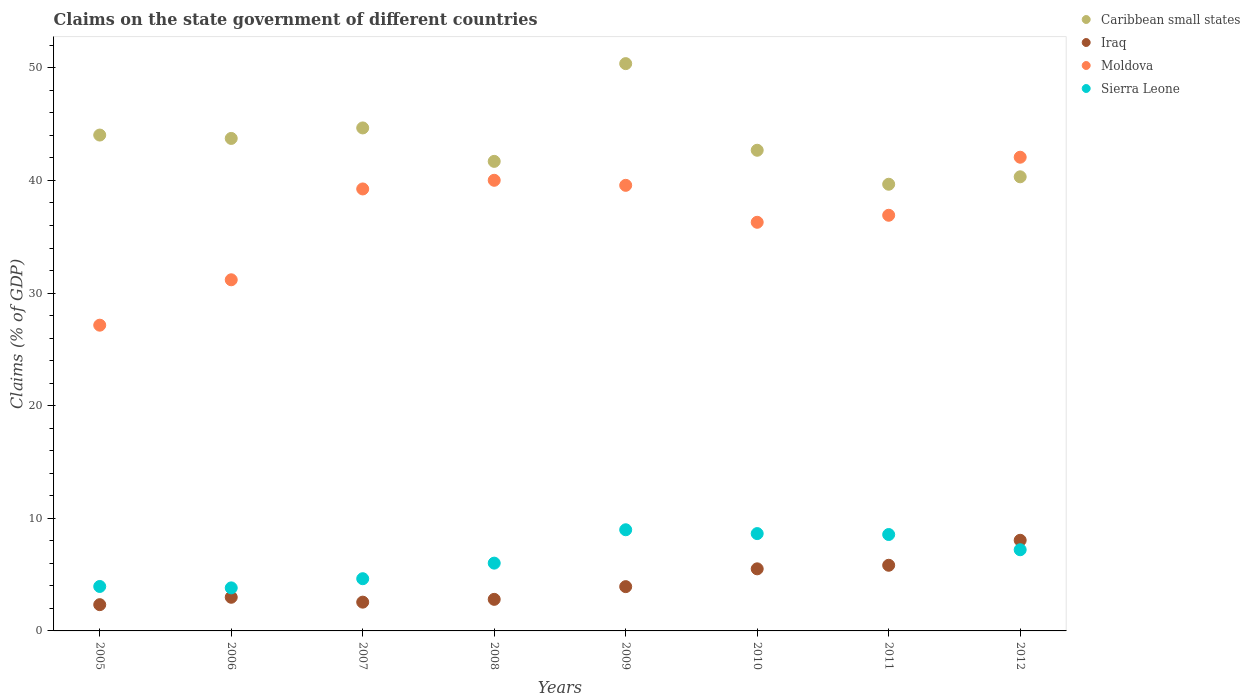Is the number of dotlines equal to the number of legend labels?
Offer a terse response. Yes. What is the percentage of GDP claimed on the state government in Caribbean small states in 2008?
Provide a short and direct response. 41.7. Across all years, what is the maximum percentage of GDP claimed on the state government in Moldova?
Make the answer very short. 42.06. Across all years, what is the minimum percentage of GDP claimed on the state government in Sierra Leone?
Your answer should be compact. 3.82. In which year was the percentage of GDP claimed on the state government in Sierra Leone minimum?
Provide a succinct answer. 2006. What is the total percentage of GDP claimed on the state government in Sierra Leone in the graph?
Ensure brevity in your answer.  51.82. What is the difference between the percentage of GDP claimed on the state government in Iraq in 2005 and that in 2009?
Give a very brief answer. -1.6. What is the difference between the percentage of GDP claimed on the state government in Caribbean small states in 2011 and the percentage of GDP claimed on the state government in Iraq in 2007?
Give a very brief answer. 37.11. What is the average percentage of GDP claimed on the state government in Moldova per year?
Your response must be concise. 36.55. In the year 2009, what is the difference between the percentage of GDP claimed on the state government in Caribbean small states and percentage of GDP claimed on the state government in Moldova?
Keep it short and to the point. 10.81. What is the ratio of the percentage of GDP claimed on the state government in Caribbean small states in 2011 to that in 2012?
Give a very brief answer. 0.98. Is the difference between the percentage of GDP claimed on the state government in Caribbean small states in 2006 and 2009 greater than the difference between the percentage of GDP claimed on the state government in Moldova in 2006 and 2009?
Provide a short and direct response. Yes. What is the difference between the highest and the second highest percentage of GDP claimed on the state government in Sierra Leone?
Provide a succinct answer. 0.34. What is the difference between the highest and the lowest percentage of GDP claimed on the state government in Moldova?
Offer a very short reply. 14.91. Is it the case that in every year, the sum of the percentage of GDP claimed on the state government in Caribbean small states and percentage of GDP claimed on the state government in Sierra Leone  is greater than the sum of percentage of GDP claimed on the state government in Moldova and percentage of GDP claimed on the state government in Iraq?
Offer a very short reply. No. Is it the case that in every year, the sum of the percentage of GDP claimed on the state government in Moldova and percentage of GDP claimed on the state government in Sierra Leone  is greater than the percentage of GDP claimed on the state government in Caribbean small states?
Provide a short and direct response. No. Is the percentage of GDP claimed on the state government in Moldova strictly greater than the percentage of GDP claimed on the state government in Sierra Leone over the years?
Keep it short and to the point. Yes. Is the percentage of GDP claimed on the state government in Caribbean small states strictly less than the percentage of GDP claimed on the state government in Moldova over the years?
Your answer should be compact. No. How many dotlines are there?
Offer a terse response. 4. What is the difference between two consecutive major ticks on the Y-axis?
Offer a terse response. 10. Where does the legend appear in the graph?
Offer a very short reply. Top right. How many legend labels are there?
Ensure brevity in your answer.  4. What is the title of the graph?
Your response must be concise. Claims on the state government of different countries. Does "Luxembourg" appear as one of the legend labels in the graph?
Keep it short and to the point. No. What is the label or title of the Y-axis?
Ensure brevity in your answer.  Claims (% of GDP). What is the Claims (% of GDP) of Caribbean small states in 2005?
Provide a succinct answer. 44.03. What is the Claims (% of GDP) of Iraq in 2005?
Your answer should be compact. 2.33. What is the Claims (% of GDP) in Moldova in 2005?
Offer a terse response. 27.15. What is the Claims (% of GDP) of Sierra Leone in 2005?
Your answer should be very brief. 3.95. What is the Claims (% of GDP) in Caribbean small states in 2006?
Keep it short and to the point. 43.73. What is the Claims (% of GDP) in Iraq in 2006?
Provide a succinct answer. 2.99. What is the Claims (% of GDP) of Moldova in 2006?
Keep it short and to the point. 31.18. What is the Claims (% of GDP) of Sierra Leone in 2006?
Your answer should be very brief. 3.82. What is the Claims (% of GDP) in Caribbean small states in 2007?
Make the answer very short. 44.67. What is the Claims (% of GDP) of Iraq in 2007?
Offer a very short reply. 2.55. What is the Claims (% of GDP) in Moldova in 2007?
Provide a succinct answer. 39.25. What is the Claims (% of GDP) in Sierra Leone in 2007?
Ensure brevity in your answer.  4.64. What is the Claims (% of GDP) of Caribbean small states in 2008?
Provide a succinct answer. 41.7. What is the Claims (% of GDP) in Iraq in 2008?
Give a very brief answer. 2.8. What is the Claims (% of GDP) of Moldova in 2008?
Provide a succinct answer. 40.02. What is the Claims (% of GDP) of Sierra Leone in 2008?
Provide a succinct answer. 6.02. What is the Claims (% of GDP) in Caribbean small states in 2009?
Provide a succinct answer. 50.38. What is the Claims (% of GDP) of Iraq in 2009?
Offer a very short reply. 3.93. What is the Claims (% of GDP) in Moldova in 2009?
Give a very brief answer. 39.57. What is the Claims (% of GDP) in Sierra Leone in 2009?
Offer a very short reply. 8.98. What is the Claims (% of GDP) of Caribbean small states in 2010?
Provide a short and direct response. 42.68. What is the Claims (% of GDP) of Iraq in 2010?
Your answer should be very brief. 5.51. What is the Claims (% of GDP) in Moldova in 2010?
Ensure brevity in your answer.  36.29. What is the Claims (% of GDP) of Sierra Leone in 2010?
Make the answer very short. 8.64. What is the Claims (% of GDP) in Caribbean small states in 2011?
Give a very brief answer. 39.66. What is the Claims (% of GDP) in Iraq in 2011?
Your answer should be compact. 5.83. What is the Claims (% of GDP) in Moldova in 2011?
Ensure brevity in your answer.  36.91. What is the Claims (% of GDP) in Sierra Leone in 2011?
Give a very brief answer. 8.56. What is the Claims (% of GDP) of Caribbean small states in 2012?
Ensure brevity in your answer.  40.33. What is the Claims (% of GDP) in Iraq in 2012?
Provide a succinct answer. 8.05. What is the Claims (% of GDP) in Moldova in 2012?
Make the answer very short. 42.06. What is the Claims (% of GDP) in Sierra Leone in 2012?
Offer a very short reply. 7.21. Across all years, what is the maximum Claims (% of GDP) of Caribbean small states?
Make the answer very short. 50.38. Across all years, what is the maximum Claims (% of GDP) of Iraq?
Your answer should be very brief. 8.05. Across all years, what is the maximum Claims (% of GDP) in Moldova?
Provide a short and direct response. 42.06. Across all years, what is the maximum Claims (% of GDP) of Sierra Leone?
Offer a terse response. 8.98. Across all years, what is the minimum Claims (% of GDP) in Caribbean small states?
Provide a succinct answer. 39.66. Across all years, what is the minimum Claims (% of GDP) of Iraq?
Your answer should be compact. 2.33. Across all years, what is the minimum Claims (% of GDP) of Moldova?
Ensure brevity in your answer.  27.15. Across all years, what is the minimum Claims (% of GDP) of Sierra Leone?
Make the answer very short. 3.82. What is the total Claims (% of GDP) of Caribbean small states in the graph?
Keep it short and to the point. 347.18. What is the total Claims (% of GDP) in Iraq in the graph?
Provide a short and direct response. 34. What is the total Claims (% of GDP) of Moldova in the graph?
Ensure brevity in your answer.  292.42. What is the total Claims (% of GDP) in Sierra Leone in the graph?
Give a very brief answer. 51.82. What is the difference between the Claims (% of GDP) of Caribbean small states in 2005 and that in 2006?
Give a very brief answer. 0.3. What is the difference between the Claims (% of GDP) of Iraq in 2005 and that in 2006?
Offer a very short reply. -0.66. What is the difference between the Claims (% of GDP) in Moldova in 2005 and that in 2006?
Offer a very short reply. -4.03. What is the difference between the Claims (% of GDP) in Sierra Leone in 2005 and that in 2006?
Your response must be concise. 0.13. What is the difference between the Claims (% of GDP) of Caribbean small states in 2005 and that in 2007?
Your answer should be compact. -0.63. What is the difference between the Claims (% of GDP) in Iraq in 2005 and that in 2007?
Keep it short and to the point. -0.22. What is the difference between the Claims (% of GDP) of Moldova in 2005 and that in 2007?
Offer a very short reply. -12.1. What is the difference between the Claims (% of GDP) in Sierra Leone in 2005 and that in 2007?
Your response must be concise. -0.69. What is the difference between the Claims (% of GDP) of Caribbean small states in 2005 and that in 2008?
Provide a short and direct response. 2.34. What is the difference between the Claims (% of GDP) of Iraq in 2005 and that in 2008?
Your response must be concise. -0.47. What is the difference between the Claims (% of GDP) of Moldova in 2005 and that in 2008?
Your answer should be very brief. -12.87. What is the difference between the Claims (% of GDP) in Sierra Leone in 2005 and that in 2008?
Provide a short and direct response. -2.07. What is the difference between the Claims (% of GDP) of Caribbean small states in 2005 and that in 2009?
Provide a short and direct response. -6.34. What is the difference between the Claims (% of GDP) in Iraq in 2005 and that in 2009?
Offer a terse response. -1.6. What is the difference between the Claims (% of GDP) in Moldova in 2005 and that in 2009?
Provide a succinct answer. -12.42. What is the difference between the Claims (% of GDP) in Sierra Leone in 2005 and that in 2009?
Offer a very short reply. -5.04. What is the difference between the Claims (% of GDP) in Caribbean small states in 2005 and that in 2010?
Your answer should be very brief. 1.35. What is the difference between the Claims (% of GDP) in Iraq in 2005 and that in 2010?
Your response must be concise. -3.18. What is the difference between the Claims (% of GDP) of Moldova in 2005 and that in 2010?
Your answer should be compact. -9.14. What is the difference between the Claims (% of GDP) in Sierra Leone in 2005 and that in 2010?
Ensure brevity in your answer.  -4.7. What is the difference between the Claims (% of GDP) of Caribbean small states in 2005 and that in 2011?
Your answer should be compact. 4.37. What is the difference between the Claims (% of GDP) of Iraq in 2005 and that in 2011?
Provide a short and direct response. -3.5. What is the difference between the Claims (% of GDP) in Moldova in 2005 and that in 2011?
Provide a short and direct response. -9.76. What is the difference between the Claims (% of GDP) in Sierra Leone in 2005 and that in 2011?
Your response must be concise. -4.61. What is the difference between the Claims (% of GDP) in Caribbean small states in 2005 and that in 2012?
Ensure brevity in your answer.  3.71. What is the difference between the Claims (% of GDP) of Iraq in 2005 and that in 2012?
Your answer should be very brief. -5.72. What is the difference between the Claims (% of GDP) in Moldova in 2005 and that in 2012?
Ensure brevity in your answer.  -14.91. What is the difference between the Claims (% of GDP) in Sierra Leone in 2005 and that in 2012?
Your answer should be compact. -3.26. What is the difference between the Claims (% of GDP) of Caribbean small states in 2006 and that in 2007?
Offer a very short reply. -0.93. What is the difference between the Claims (% of GDP) in Iraq in 2006 and that in 2007?
Your response must be concise. 0.43. What is the difference between the Claims (% of GDP) of Moldova in 2006 and that in 2007?
Ensure brevity in your answer.  -8.07. What is the difference between the Claims (% of GDP) of Sierra Leone in 2006 and that in 2007?
Your response must be concise. -0.81. What is the difference between the Claims (% of GDP) of Caribbean small states in 2006 and that in 2008?
Offer a terse response. 2.04. What is the difference between the Claims (% of GDP) in Iraq in 2006 and that in 2008?
Your answer should be very brief. 0.18. What is the difference between the Claims (% of GDP) of Moldova in 2006 and that in 2008?
Ensure brevity in your answer.  -8.84. What is the difference between the Claims (% of GDP) of Sierra Leone in 2006 and that in 2008?
Keep it short and to the point. -2.2. What is the difference between the Claims (% of GDP) in Caribbean small states in 2006 and that in 2009?
Ensure brevity in your answer.  -6.64. What is the difference between the Claims (% of GDP) in Iraq in 2006 and that in 2009?
Your answer should be very brief. -0.94. What is the difference between the Claims (% of GDP) in Moldova in 2006 and that in 2009?
Make the answer very short. -8.39. What is the difference between the Claims (% of GDP) of Sierra Leone in 2006 and that in 2009?
Your answer should be compact. -5.16. What is the difference between the Claims (% of GDP) in Caribbean small states in 2006 and that in 2010?
Ensure brevity in your answer.  1.05. What is the difference between the Claims (% of GDP) in Iraq in 2006 and that in 2010?
Your answer should be compact. -2.52. What is the difference between the Claims (% of GDP) of Moldova in 2006 and that in 2010?
Provide a short and direct response. -5.11. What is the difference between the Claims (% of GDP) of Sierra Leone in 2006 and that in 2010?
Give a very brief answer. -4.82. What is the difference between the Claims (% of GDP) of Caribbean small states in 2006 and that in 2011?
Keep it short and to the point. 4.07. What is the difference between the Claims (% of GDP) in Iraq in 2006 and that in 2011?
Your answer should be very brief. -2.84. What is the difference between the Claims (% of GDP) of Moldova in 2006 and that in 2011?
Give a very brief answer. -5.73. What is the difference between the Claims (% of GDP) of Sierra Leone in 2006 and that in 2011?
Give a very brief answer. -4.74. What is the difference between the Claims (% of GDP) in Caribbean small states in 2006 and that in 2012?
Ensure brevity in your answer.  3.41. What is the difference between the Claims (% of GDP) in Iraq in 2006 and that in 2012?
Give a very brief answer. -5.06. What is the difference between the Claims (% of GDP) in Moldova in 2006 and that in 2012?
Your response must be concise. -10.88. What is the difference between the Claims (% of GDP) of Sierra Leone in 2006 and that in 2012?
Keep it short and to the point. -3.39. What is the difference between the Claims (% of GDP) in Caribbean small states in 2007 and that in 2008?
Your answer should be compact. 2.97. What is the difference between the Claims (% of GDP) in Iraq in 2007 and that in 2008?
Offer a terse response. -0.25. What is the difference between the Claims (% of GDP) in Moldova in 2007 and that in 2008?
Make the answer very short. -0.77. What is the difference between the Claims (% of GDP) of Sierra Leone in 2007 and that in 2008?
Your response must be concise. -1.38. What is the difference between the Claims (% of GDP) in Caribbean small states in 2007 and that in 2009?
Your answer should be compact. -5.71. What is the difference between the Claims (% of GDP) of Iraq in 2007 and that in 2009?
Provide a succinct answer. -1.38. What is the difference between the Claims (% of GDP) in Moldova in 2007 and that in 2009?
Your answer should be compact. -0.32. What is the difference between the Claims (% of GDP) of Sierra Leone in 2007 and that in 2009?
Give a very brief answer. -4.35. What is the difference between the Claims (% of GDP) in Caribbean small states in 2007 and that in 2010?
Provide a succinct answer. 1.98. What is the difference between the Claims (% of GDP) of Iraq in 2007 and that in 2010?
Your answer should be compact. -2.96. What is the difference between the Claims (% of GDP) in Moldova in 2007 and that in 2010?
Offer a terse response. 2.96. What is the difference between the Claims (% of GDP) of Sierra Leone in 2007 and that in 2010?
Make the answer very short. -4.01. What is the difference between the Claims (% of GDP) in Caribbean small states in 2007 and that in 2011?
Your answer should be compact. 5. What is the difference between the Claims (% of GDP) of Iraq in 2007 and that in 2011?
Offer a terse response. -3.28. What is the difference between the Claims (% of GDP) in Moldova in 2007 and that in 2011?
Provide a short and direct response. 2.34. What is the difference between the Claims (% of GDP) in Sierra Leone in 2007 and that in 2011?
Give a very brief answer. -3.92. What is the difference between the Claims (% of GDP) of Caribbean small states in 2007 and that in 2012?
Offer a very short reply. 4.34. What is the difference between the Claims (% of GDP) in Iraq in 2007 and that in 2012?
Ensure brevity in your answer.  -5.49. What is the difference between the Claims (% of GDP) of Moldova in 2007 and that in 2012?
Ensure brevity in your answer.  -2.82. What is the difference between the Claims (% of GDP) of Sierra Leone in 2007 and that in 2012?
Give a very brief answer. -2.57. What is the difference between the Claims (% of GDP) in Caribbean small states in 2008 and that in 2009?
Make the answer very short. -8.68. What is the difference between the Claims (% of GDP) in Iraq in 2008 and that in 2009?
Keep it short and to the point. -1.13. What is the difference between the Claims (% of GDP) of Moldova in 2008 and that in 2009?
Offer a terse response. 0.45. What is the difference between the Claims (% of GDP) of Sierra Leone in 2008 and that in 2009?
Your answer should be very brief. -2.96. What is the difference between the Claims (% of GDP) in Caribbean small states in 2008 and that in 2010?
Provide a short and direct response. -0.99. What is the difference between the Claims (% of GDP) in Iraq in 2008 and that in 2010?
Keep it short and to the point. -2.71. What is the difference between the Claims (% of GDP) of Moldova in 2008 and that in 2010?
Give a very brief answer. 3.73. What is the difference between the Claims (% of GDP) of Sierra Leone in 2008 and that in 2010?
Provide a short and direct response. -2.62. What is the difference between the Claims (% of GDP) of Caribbean small states in 2008 and that in 2011?
Your answer should be compact. 2.03. What is the difference between the Claims (% of GDP) in Iraq in 2008 and that in 2011?
Your response must be concise. -3.03. What is the difference between the Claims (% of GDP) of Moldova in 2008 and that in 2011?
Offer a very short reply. 3.11. What is the difference between the Claims (% of GDP) of Sierra Leone in 2008 and that in 2011?
Your response must be concise. -2.54. What is the difference between the Claims (% of GDP) of Caribbean small states in 2008 and that in 2012?
Provide a succinct answer. 1.37. What is the difference between the Claims (% of GDP) in Iraq in 2008 and that in 2012?
Your answer should be compact. -5.24. What is the difference between the Claims (% of GDP) of Moldova in 2008 and that in 2012?
Your answer should be very brief. -2.05. What is the difference between the Claims (% of GDP) of Sierra Leone in 2008 and that in 2012?
Keep it short and to the point. -1.19. What is the difference between the Claims (% of GDP) in Caribbean small states in 2009 and that in 2010?
Your answer should be compact. 7.69. What is the difference between the Claims (% of GDP) of Iraq in 2009 and that in 2010?
Provide a short and direct response. -1.58. What is the difference between the Claims (% of GDP) of Moldova in 2009 and that in 2010?
Your response must be concise. 3.28. What is the difference between the Claims (% of GDP) in Sierra Leone in 2009 and that in 2010?
Make the answer very short. 0.34. What is the difference between the Claims (% of GDP) of Caribbean small states in 2009 and that in 2011?
Your answer should be very brief. 10.71. What is the difference between the Claims (% of GDP) in Iraq in 2009 and that in 2011?
Provide a short and direct response. -1.9. What is the difference between the Claims (% of GDP) in Moldova in 2009 and that in 2011?
Give a very brief answer. 2.66. What is the difference between the Claims (% of GDP) in Sierra Leone in 2009 and that in 2011?
Keep it short and to the point. 0.42. What is the difference between the Claims (% of GDP) in Caribbean small states in 2009 and that in 2012?
Keep it short and to the point. 10.05. What is the difference between the Claims (% of GDP) of Iraq in 2009 and that in 2012?
Provide a short and direct response. -4.12. What is the difference between the Claims (% of GDP) in Moldova in 2009 and that in 2012?
Keep it short and to the point. -2.5. What is the difference between the Claims (% of GDP) in Sierra Leone in 2009 and that in 2012?
Offer a very short reply. 1.77. What is the difference between the Claims (% of GDP) of Caribbean small states in 2010 and that in 2011?
Provide a short and direct response. 3.02. What is the difference between the Claims (% of GDP) in Iraq in 2010 and that in 2011?
Your answer should be compact. -0.32. What is the difference between the Claims (% of GDP) in Moldova in 2010 and that in 2011?
Your answer should be very brief. -0.62. What is the difference between the Claims (% of GDP) in Sierra Leone in 2010 and that in 2011?
Give a very brief answer. 0.08. What is the difference between the Claims (% of GDP) in Caribbean small states in 2010 and that in 2012?
Your answer should be very brief. 2.36. What is the difference between the Claims (% of GDP) of Iraq in 2010 and that in 2012?
Offer a very short reply. -2.54. What is the difference between the Claims (% of GDP) in Moldova in 2010 and that in 2012?
Provide a succinct answer. -5.78. What is the difference between the Claims (% of GDP) of Sierra Leone in 2010 and that in 2012?
Offer a terse response. 1.44. What is the difference between the Claims (% of GDP) of Caribbean small states in 2011 and that in 2012?
Provide a succinct answer. -0.66. What is the difference between the Claims (% of GDP) of Iraq in 2011 and that in 2012?
Your response must be concise. -2.22. What is the difference between the Claims (% of GDP) of Moldova in 2011 and that in 2012?
Your answer should be compact. -5.15. What is the difference between the Claims (% of GDP) of Sierra Leone in 2011 and that in 2012?
Your response must be concise. 1.35. What is the difference between the Claims (% of GDP) of Caribbean small states in 2005 and the Claims (% of GDP) of Iraq in 2006?
Offer a very short reply. 41.05. What is the difference between the Claims (% of GDP) in Caribbean small states in 2005 and the Claims (% of GDP) in Moldova in 2006?
Provide a short and direct response. 12.85. What is the difference between the Claims (% of GDP) in Caribbean small states in 2005 and the Claims (% of GDP) in Sierra Leone in 2006?
Provide a succinct answer. 40.21. What is the difference between the Claims (% of GDP) in Iraq in 2005 and the Claims (% of GDP) in Moldova in 2006?
Provide a succinct answer. -28.85. What is the difference between the Claims (% of GDP) of Iraq in 2005 and the Claims (% of GDP) of Sierra Leone in 2006?
Keep it short and to the point. -1.49. What is the difference between the Claims (% of GDP) in Moldova in 2005 and the Claims (% of GDP) in Sierra Leone in 2006?
Your answer should be compact. 23.33. What is the difference between the Claims (% of GDP) in Caribbean small states in 2005 and the Claims (% of GDP) in Iraq in 2007?
Offer a very short reply. 41.48. What is the difference between the Claims (% of GDP) in Caribbean small states in 2005 and the Claims (% of GDP) in Moldova in 2007?
Your answer should be very brief. 4.79. What is the difference between the Claims (% of GDP) of Caribbean small states in 2005 and the Claims (% of GDP) of Sierra Leone in 2007?
Keep it short and to the point. 39.4. What is the difference between the Claims (% of GDP) of Iraq in 2005 and the Claims (% of GDP) of Moldova in 2007?
Give a very brief answer. -36.92. What is the difference between the Claims (% of GDP) of Iraq in 2005 and the Claims (% of GDP) of Sierra Leone in 2007?
Keep it short and to the point. -2.31. What is the difference between the Claims (% of GDP) of Moldova in 2005 and the Claims (% of GDP) of Sierra Leone in 2007?
Your answer should be very brief. 22.51. What is the difference between the Claims (% of GDP) of Caribbean small states in 2005 and the Claims (% of GDP) of Iraq in 2008?
Give a very brief answer. 41.23. What is the difference between the Claims (% of GDP) in Caribbean small states in 2005 and the Claims (% of GDP) in Moldova in 2008?
Offer a terse response. 4.02. What is the difference between the Claims (% of GDP) of Caribbean small states in 2005 and the Claims (% of GDP) of Sierra Leone in 2008?
Offer a terse response. 38.01. What is the difference between the Claims (% of GDP) in Iraq in 2005 and the Claims (% of GDP) in Moldova in 2008?
Ensure brevity in your answer.  -37.68. What is the difference between the Claims (% of GDP) of Iraq in 2005 and the Claims (% of GDP) of Sierra Leone in 2008?
Give a very brief answer. -3.69. What is the difference between the Claims (% of GDP) of Moldova in 2005 and the Claims (% of GDP) of Sierra Leone in 2008?
Provide a succinct answer. 21.13. What is the difference between the Claims (% of GDP) in Caribbean small states in 2005 and the Claims (% of GDP) in Iraq in 2009?
Your answer should be very brief. 40.1. What is the difference between the Claims (% of GDP) in Caribbean small states in 2005 and the Claims (% of GDP) in Moldova in 2009?
Make the answer very short. 4.47. What is the difference between the Claims (% of GDP) of Caribbean small states in 2005 and the Claims (% of GDP) of Sierra Leone in 2009?
Your answer should be very brief. 35.05. What is the difference between the Claims (% of GDP) of Iraq in 2005 and the Claims (% of GDP) of Moldova in 2009?
Give a very brief answer. -37.24. What is the difference between the Claims (% of GDP) in Iraq in 2005 and the Claims (% of GDP) in Sierra Leone in 2009?
Your answer should be compact. -6.65. What is the difference between the Claims (% of GDP) in Moldova in 2005 and the Claims (% of GDP) in Sierra Leone in 2009?
Give a very brief answer. 18.17. What is the difference between the Claims (% of GDP) of Caribbean small states in 2005 and the Claims (% of GDP) of Iraq in 2010?
Offer a terse response. 38.52. What is the difference between the Claims (% of GDP) of Caribbean small states in 2005 and the Claims (% of GDP) of Moldova in 2010?
Provide a succinct answer. 7.75. What is the difference between the Claims (% of GDP) of Caribbean small states in 2005 and the Claims (% of GDP) of Sierra Leone in 2010?
Keep it short and to the point. 35.39. What is the difference between the Claims (% of GDP) in Iraq in 2005 and the Claims (% of GDP) in Moldova in 2010?
Keep it short and to the point. -33.96. What is the difference between the Claims (% of GDP) of Iraq in 2005 and the Claims (% of GDP) of Sierra Leone in 2010?
Keep it short and to the point. -6.31. What is the difference between the Claims (% of GDP) of Moldova in 2005 and the Claims (% of GDP) of Sierra Leone in 2010?
Provide a succinct answer. 18.51. What is the difference between the Claims (% of GDP) in Caribbean small states in 2005 and the Claims (% of GDP) in Iraq in 2011?
Your response must be concise. 38.2. What is the difference between the Claims (% of GDP) in Caribbean small states in 2005 and the Claims (% of GDP) in Moldova in 2011?
Provide a short and direct response. 7.12. What is the difference between the Claims (% of GDP) of Caribbean small states in 2005 and the Claims (% of GDP) of Sierra Leone in 2011?
Give a very brief answer. 35.47. What is the difference between the Claims (% of GDP) of Iraq in 2005 and the Claims (% of GDP) of Moldova in 2011?
Your answer should be compact. -34.58. What is the difference between the Claims (% of GDP) of Iraq in 2005 and the Claims (% of GDP) of Sierra Leone in 2011?
Offer a very short reply. -6.23. What is the difference between the Claims (% of GDP) of Moldova in 2005 and the Claims (% of GDP) of Sierra Leone in 2011?
Make the answer very short. 18.59. What is the difference between the Claims (% of GDP) of Caribbean small states in 2005 and the Claims (% of GDP) of Iraq in 2012?
Offer a terse response. 35.98. What is the difference between the Claims (% of GDP) in Caribbean small states in 2005 and the Claims (% of GDP) in Moldova in 2012?
Your response must be concise. 1.97. What is the difference between the Claims (% of GDP) in Caribbean small states in 2005 and the Claims (% of GDP) in Sierra Leone in 2012?
Give a very brief answer. 36.83. What is the difference between the Claims (% of GDP) in Iraq in 2005 and the Claims (% of GDP) in Moldova in 2012?
Make the answer very short. -39.73. What is the difference between the Claims (% of GDP) in Iraq in 2005 and the Claims (% of GDP) in Sierra Leone in 2012?
Offer a very short reply. -4.88. What is the difference between the Claims (% of GDP) of Moldova in 2005 and the Claims (% of GDP) of Sierra Leone in 2012?
Provide a short and direct response. 19.94. What is the difference between the Claims (% of GDP) of Caribbean small states in 2006 and the Claims (% of GDP) of Iraq in 2007?
Provide a succinct answer. 41.18. What is the difference between the Claims (% of GDP) of Caribbean small states in 2006 and the Claims (% of GDP) of Moldova in 2007?
Your answer should be compact. 4.49. What is the difference between the Claims (% of GDP) in Caribbean small states in 2006 and the Claims (% of GDP) in Sierra Leone in 2007?
Ensure brevity in your answer.  39.1. What is the difference between the Claims (% of GDP) of Iraq in 2006 and the Claims (% of GDP) of Moldova in 2007?
Keep it short and to the point. -36.26. What is the difference between the Claims (% of GDP) of Iraq in 2006 and the Claims (% of GDP) of Sierra Leone in 2007?
Offer a terse response. -1.65. What is the difference between the Claims (% of GDP) in Moldova in 2006 and the Claims (% of GDP) in Sierra Leone in 2007?
Your response must be concise. 26.54. What is the difference between the Claims (% of GDP) of Caribbean small states in 2006 and the Claims (% of GDP) of Iraq in 2008?
Offer a terse response. 40.93. What is the difference between the Claims (% of GDP) of Caribbean small states in 2006 and the Claims (% of GDP) of Moldova in 2008?
Provide a short and direct response. 3.72. What is the difference between the Claims (% of GDP) of Caribbean small states in 2006 and the Claims (% of GDP) of Sierra Leone in 2008?
Keep it short and to the point. 37.71. What is the difference between the Claims (% of GDP) in Iraq in 2006 and the Claims (% of GDP) in Moldova in 2008?
Keep it short and to the point. -37.03. What is the difference between the Claims (% of GDP) of Iraq in 2006 and the Claims (% of GDP) of Sierra Leone in 2008?
Offer a terse response. -3.03. What is the difference between the Claims (% of GDP) of Moldova in 2006 and the Claims (% of GDP) of Sierra Leone in 2008?
Your response must be concise. 25.16. What is the difference between the Claims (% of GDP) of Caribbean small states in 2006 and the Claims (% of GDP) of Iraq in 2009?
Your response must be concise. 39.8. What is the difference between the Claims (% of GDP) in Caribbean small states in 2006 and the Claims (% of GDP) in Moldova in 2009?
Your answer should be compact. 4.17. What is the difference between the Claims (% of GDP) of Caribbean small states in 2006 and the Claims (% of GDP) of Sierra Leone in 2009?
Keep it short and to the point. 34.75. What is the difference between the Claims (% of GDP) of Iraq in 2006 and the Claims (% of GDP) of Moldova in 2009?
Offer a terse response. -36.58. What is the difference between the Claims (% of GDP) of Iraq in 2006 and the Claims (% of GDP) of Sierra Leone in 2009?
Keep it short and to the point. -5.99. What is the difference between the Claims (% of GDP) of Moldova in 2006 and the Claims (% of GDP) of Sierra Leone in 2009?
Offer a terse response. 22.2. What is the difference between the Claims (% of GDP) of Caribbean small states in 2006 and the Claims (% of GDP) of Iraq in 2010?
Offer a very short reply. 38.22. What is the difference between the Claims (% of GDP) in Caribbean small states in 2006 and the Claims (% of GDP) in Moldova in 2010?
Your answer should be compact. 7.45. What is the difference between the Claims (% of GDP) in Caribbean small states in 2006 and the Claims (% of GDP) in Sierra Leone in 2010?
Keep it short and to the point. 35.09. What is the difference between the Claims (% of GDP) of Iraq in 2006 and the Claims (% of GDP) of Moldova in 2010?
Keep it short and to the point. -33.3. What is the difference between the Claims (% of GDP) of Iraq in 2006 and the Claims (% of GDP) of Sierra Leone in 2010?
Make the answer very short. -5.66. What is the difference between the Claims (% of GDP) of Moldova in 2006 and the Claims (% of GDP) of Sierra Leone in 2010?
Offer a terse response. 22.54. What is the difference between the Claims (% of GDP) in Caribbean small states in 2006 and the Claims (% of GDP) in Iraq in 2011?
Keep it short and to the point. 37.9. What is the difference between the Claims (% of GDP) of Caribbean small states in 2006 and the Claims (% of GDP) of Moldova in 2011?
Give a very brief answer. 6.82. What is the difference between the Claims (% of GDP) of Caribbean small states in 2006 and the Claims (% of GDP) of Sierra Leone in 2011?
Keep it short and to the point. 35.17. What is the difference between the Claims (% of GDP) of Iraq in 2006 and the Claims (% of GDP) of Moldova in 2011?
Keep it short and to the point. -33.92. What is the difference between the Claims (% of GDP) in Iraq in 2006 and the Claims (% of GDP) in Sierra Leone in 2011?
Provide a short and direct response. -5.57. What is the difference between the Claims (% of GDP) in Moldova in 2006 and the Claims (% of GDP) in Sierra Leone in 2011?
Offer a very short reply. 22.62. What is the difference between the Claims (% of GDP) in Caribbean small states in 2006 and the Claims (% of GDP) in Iraq in 2012?
Ensure brevity in your answer.  35.68. What is the difference between the Claims (% of GDP) of Caribbean small states in 2006 and the Claims (% of GDP) of Moldova in 2012?
Your answer should be compact. 1.67. What is the difference between the Claims (% of GDP) of Caribbean small states in 2006 and the Claims (% of GDP) of Sierra Leone in 2012?
Give a very brief answer. 36.53. What is the difference between the Claims (% of GDP) of Iraq in 2006 and the Claims (% of GDP) of Moldova in 2012?
Your response must be concise. -39.08. What is the difference between the Claims (% of GDP) of Iraq in 2006 and the Claims (% of GDP) of Sierra Leone in 2012?
Your answer should be compact. -4.22. What is the difference between the Claims (% of GDP) of Moldova in 2006 and the Claims (% of GDP) of Sierra Leone in 2012?
Offer a terse response. 23.97. What is the difference between the Claims (% of GDP) of Caribbean small states in 2007 and the Claims (% of GDP) of Iraq in 2008?
Offer a very short reply. 41.86. What is the difference between the Claims (% of GDP) in Caribbean small states in 2007 and the Claims (% of GDP) in Moldova in 2008?
Ensure brevity in your answer.  4.65. What is the difference between the Claims (% of GDP) in Caribbean small states in 2007 and the Claims (% of GDP) in Sierra Leone in 2008?
Your answer should be compact. 38.65. What is the difference between the Claims (% of GDP) of Iraq in 2007 and the Claims (% of GDP) of Moldova in 2008?
Provide a short and direct response. -37.46. What is the difference between the Claims (% of GDP) in Iraq in 2007 and the Claims (% of GDP) in Sierra Leone in 2008?
Offer a terse response. -3.47. What is the difference between the Claims (% of GDP) in Moldova in 2007 and the Claims (% of GDP) in Sierra Leone in 2008?
Keep it short and to the point. 33.23. What is the difference between the Claims (% of GDP) of Caribbean small states in 2007 and the Claims (% of GDP) of Iraq in 2009?
Ensure brevity in your answer.  40.73. What is the difference between the Claims (% of GDP) of Caribbean small states in 2007 and the Claims (% of GDP) of Moldova in 2009?
Offer a terse response. 5.1. What is the difference between the Claims (% of GDP) of Caribbean small states in 2007 and the Claims (% of GDP) of Sierra Leone in 2009?
Provide a short and direct response. 35.68. What is the difference between the Claims (% of GDP) of Iraq in 2007 and the Claims (% of GDP) of Moldova in 2009?
Provide a short and direct response. -37.01. What is the difference between the Claims (% of GDP) of Iraq in 2007 and the Claims (% of GDP) of Sierra Leone in 2009?
Offer a terse response. -6.43. What is the difference between the Claims (% of GDP) of Moldova in 2007 and the Claims (% of GDP) of Sierra Leone in 2009?
Your response must be concise. 30.27. What is the difference between the Claims (% of GDP) in Caribbean small states in 2007 and the Claims (% of GDP) in Iraq in 2010?
Offer a terse response. 39.15. What is the difference between the Claims (% of GDP) in Caribbean small states in 2007 and the Claims (% of GDP) in Moldova in 2010?
Ensure brevity in your answer.  8.38. What is the difference between the Claims (% of GDP) of Caribbean small states in 2007 and the Claims (% of GDP) of Sierra Leone in 2010?
Your response must be concise. 36.02. What is the difference between the Claims (% of GDP) of Iraq in 2007 and the Claims (% of GDP) of Moldova in 2010?
Keep it short and to the point. -33.73. What is the difference between the Claims (% of GDP) of Iraq in 2007 and the Claims (% of GDP) of Sierra Leone in 2010?
Give a very brief answer. -6.09. What is the difference between the Claims (% of GDP) in Moldova in 2007 and the Claims (% of GDP) in Sierra Leone in 2010?
Provide a short and direct response. 30.6. What is the difference between the Claims (% of GDP) in Caribbean small states in 2007 and the Claims (% of GDP) in Iraq in 2011?
Provide a succinct answer. 38.84. What is the difference between the Claims (% of GDP) of Caribbean small states in 2007 and the Claims (% of GDP) of Moldova in 2011?
Offer a terse response. 7.76. What is the difference between the Claims (% of GDP) of Caribbean small states in 2007 and the Claims (% of GDP) of Sierra Leone in 2011?
Your answer should be compact. 36.1. What is the difference between the Claims (% of GDP) of Iraq in 2007 and the Claims (% of GDP) of Moldova in 2011?
Give a very brief answer. -34.36. What is the difference between the Claims (% of GDP) of Iraq in 2007 and the Claims (% of GDP) of Sierra Leone in 2011?
Provide a succinct answer. -6.01. What is the difference between the Claims (% of GDP) in Moldova in 2007 and the Claims (% of GDP) in Sierra Leone in 2011?
Offer a very short reply. 30.69. What is the difference between the Claims (% of GDP) in Caribbean small states in 2007 and the Claims (% of GDP) in Iraq in 2012?
Offer a very short reply. 36.62. What is the difference between the Claims (% of GDP) of Caribbean small states in 2007 and the Claims (% of GDP) of Moldova in 2012?
Keep it short and to the point. 2.6. What is the difference between the Claims (% of GDP) in Caribbean small states in 2007 and the Claims (% of GDP) in Sierra Leone in 2012?
Your response must be concise. 37.46. What is the difference between the Claims (% of GDP) in Iraq in 2007 and the Claims (% of GDP) in Moldova in 2012?
Your answer should be very brief. -39.51. What is the difference between the Claims (% of GDP) of Iraq in 2007 and the Claims (% of GDP) of Sierra Leone in 2012?
Offer a very short reply. -4.65. What is the difference between the Claims (% of GDP) of Moldova in 2007 and the Claims (% of GDP) of Sierra Leone in 2012?
Your answer should be compact. 32.04. What is the difference between the Claims (% of GDP) in Caribbean small states in 2008 and the Claims (% of GDP) in Iraq in 2009?
Offer a terse response. 37.76. What is the difference between the Claims (% of GDP) of Caribbean small states in 2008 and the Claims (% of GDP) of Moldova in 2009?
Your answer should be compact. 2.13. What is the difference between the Claims (% of GDP) of Caribbean small states in 2008 and the Claims (% of GDP) of Sierra Leone in 2009?
Your response must be concise. 32.71. What is the difference between the Claims (% of GDP) of Iraq in 2008 and the Claims (% of GDP) of Moldova in 2009?
Your answer should be compact. -36.76. What is the difference between the Claims (% of GDP) of Iraq in 2008 and the Claims (% of GDP) of Sierra Leone in 2009?
Provide a short and direct response. -6.18. What is the difference between the Claims (% of GDP) of Moldova in 2008 and the Claims (% of GDP) of Sierra Leone in 2009?
Your response must be concise. 31.03. What is the difference between the Claims (% of GDP) of Caribbean small states in 2008 and the Claims (% of GDP) of Iraq in 2010?
Ensure brevity in your answer.  36.18. What is the difference between the Claims (% of GDP) of Caribbean small states in 2008 and the Claims (% of GDP) of Moldova in 2010?
Offer a terse response. 5.41. What is the difference between the Claims (% of GDP) in Caribbean small states in 2008 and the Claims (% of GDP) in Sierra Leone in 2010?
Your answer should be very brief. 33.05. What is the difference between the Claims (% of GDP) in Iraq in 2008 and the Claims (% of GDP) in Moldova in 2010?
Your response must be concise. -33.48. What is the difference between the Claims (% of GDP) of Iraq in 2008 and the Claims (% of GDP) of Sierra Leone in 2010?
Make the answer very short. -5.84. What is the difference between the Claims (% of GDP) in Moldova in 2008 and the Claims (% of GDP) in Sierra Leone in 2010?
Give a very brief answer. 31.37. What is the difference between the Claims (% of GDP) of Caribbean small states in 2008 and the Claims (% of GDP) of Iraq in 2011?
Keep it short and to the point. 35.87. What is the difference between the Claims (% of GDP) of Caribbean small states in 2008 and the Claims (% of GDP) of Moldova in 2011?
Your answer should be very brief. 4.79. What is the difference between the Claims (% of GDP) of Caribbean small states in 2008 and the Claims (% of GDP) of Sierra Leone in 2011?
Ensure brevity in your answer.  33.14. What is the difference between the Claims (% of GDP) in Iraq in 2008 and the Claims (% of GDP) in Moldova in 2011?
Your answer should be very brief. -34.11. What is the difference between the Claims (% of GDP) of Iraq in 2008 and the Claims (% of GDP) of Sierra Leone in 2011?
Provide a short and direct response. -5.76. What is the difference between the Claims (% of GDP) of Moldova in 2008 and the Claims (% of GDP) of Sierra Leone in 2011?
Your answer should be compact. 31.46. What is the difference between the Claims (% of GDP) of Caribbean small states in 2008 and the Claims (% of GDP) of Iraq in 2012?
Make the answer very short. 33.65. What is the difference between the Claims (% of GDP) of Caribbean small states in 2008 and the Claims (% of GDP) of Moldova in 2012?
Make the answer very short. -0.37. What is the difference between the Claims (% of GDP) in Caribbean small states in 2008 and the Claims (% of GDP) in Sierra Leone in 2012?
Offer a very short reply. 34.49. What is the difference between the Claims (% of GDP) in Iraq in 2008 and the Claims (% of GDP) in Moldova in 2012?
Your answer should be compact. -39.26. What is the difference between the Claims (% of GDP) in Iraq in 2008 and the Claims (% of GDP) in Sierra Leone in 2012?
Give a very brief answer. -4.4. What is the difference between the Claims (% of GDP) in Moldova in 2008 and the Claims (% of GDP) in Sierra Leone in 2012?
Keep it short and to the point. 32.81. What is the difference between the Claims (% of GDP) in Caribbean small states in 2009 and the Claims (% of GDP) in Iraq in 2010?
Keep it short and to the point. 44.86. What is the difference between the Claims (% of GDP) in Caribbean small states in 2009 and the Claims (% of GDP) in Moldova in 2010?
Your answer should be compact. 14.09. What is the difference between the Claims (% of GDP) of Caribbean small states in 2009 and the Claims (% of GDP) of Sierra Leone in 2010?
Make the answer very short. 41.73. What is the difference between the Claims (% of GDP) of Iraq in 2009 and the Claims (% of GDP) of Moldova in 2010?
Provide a short and direct response. -32.35. What is the difference between the Claims (% of GDP) of Iraq in 2009 and the Claims (% of GDP) of Sierra Leone in 2010?
Offer a terse response. -4.71. What is the difference between the Claims (% of GDP) of Moldova in 2009 and the Claims (% of GDP) of Sierra Leone in 2010?
Provide a succinct answer. 30.93. What is the difference between the Claims (% of GDP) of Caribbean small states in 2009 and the Claims (% of GDP) of Iraq in 2011?
Make the answer very short. 44.55. What is the difference between the Claims (% of GDP) in Caribbean small states in 2009 and the Claims (% of GDP) in Moldova in 2011?
Your answer should be compact. 13.47. What is the difference between the Claims (% of GDP) in Caribbean small states in 2009 and the Claims (% of GDP) in Sierra Leone in 2011?
Provide a succinct answer. 41.81. What is the difference between the Claims (% of GDP) in Iraq in 2009 and the Claims (% of GDP) in Moldova in 2011?
Give a very brief answer. -32.98. What is the difference between the Claims (% of GDP) of Iraq in 2009 and the Claims (% of GDP) of Sierra Leone in 2011?
Ensure brevity in your answer.  -4.63. What is the difference between the Claims (% of GDP) of Moldova in 2009 and the Claims (% of GDP) of Sierra Leone in 2011?
Provide a succinct answer. 31.01. What is the difference between the Claims (% of GDP) in Caribbean small states in 2009 and the Claims (% of GDP) in Iraq in 2012?
Ensure brevity in your answer.  42.33. What is the difference between the Claims (% of GDP) in Caribbean small states in 2009 and the Claims (% of GDP) in Moldova in 2012?
Your answer should be very brief. 8.31. What is the difference between the Claims (% of GDP) in Caribbean small states in 2009 and the Claims (% of GDP) in Sierra Leone in 2012?
Make the answer very short. 43.17. What is the difference between the Claims (% of GDP) in Iraq in 2009 and the Claims (% of GDP) in Moldova in 2012?
Offer a terse response. -38.13. What is the difference between the Claims (% of GDP) of Iraq in 2009 and the Claims (% of GDP) of Sierra Leone in 2012?
Provide a short and direct response. -3.28. What is the difference between the Claims (% of GDP) in Moldova in 2009 and the Claims (% of GDP) in Sierra Leone in 2012?
Make the answer very short. 32.36. What is the difference between the Claims (% of GDP) in Caribbean small states in 2010 and the Claims (% of GDP) in Iraq in 2011?
Give a very brief answer. 36.85. What is the difference between the Claims (% of GDP) of Caribbean small states in 2010 and the Claims (% of GDP) of Moldova in 2011?
Provide a short and direct response. 5.77. What is the difference between the Claims (% of GDP) of Caribbean small states in 2010 and the Claims (% of GDP) of Sierra Leone in 2011?
Keep it short and to the point. 34.12. What is the difference between the Claims (% of GDP) in Iraq in 2010 and the Claims (% of GDP) in Moldova in 2011?
Give a very brief answer. -31.4. What is the difference between the Claims (% of GDP) of Iraq in 2010 and the Claims (% of GDP) of Sierra Leone in 2011?
Offer a terse response. -3.05. What is the difference between the Claims (% of GDP) of Moldova in 2010 and the Claims (% of GDP) of Sierra Leone in 2011?
Your answer should be very brief. 27.73. What is the difference between the Claims (% of GDP) of Caribbean small states in 2010 and the Claims (% of GDP) of Iraq in 2012?
Your answer should be very brief. 34.63. What is the difference between the Claims (% of GDP) in Caribbean small states in 2010 and the Claims (% of GDP) in Moldova in 2012?
Ensure brevity in your answer.  0.62. What is the difference between the Claims (% of GDP) in Caribbean small states in 2010 and the Claims (% of GDP) in Sierra Leone in 2012?
Your answer should be very brief. 35.47. What is the difference between the Claims (% of GDP) in Iraq in 2010 and the Claims (% of GDP) in Moldova in 2012?
Keep it short and to the point. -36.55. What is the difference between the Claims (% of GDP) of Iraq in 2010 and the Claims (% of GDP) of Sierra Leone in 2012?
Your answer should be very brief. -1.7. What is the difference between the Claims (% of GDP) in Moldova in 2010 and the Claims (% of GDP) in Sierra Leone in 2012?
Your response must be concise. 29.08. What is the difference between the Claims (% of GDP) of Caribbean small states in 2011 and the Claims (% of GDP) of Iraq in 2012?
Your answer should be compact. 31.62. What is the difference between the Claims (% of GDP) in Caribbean small states in 2011 and the Claims (% of GDP) in Moldova in 2012?
Your answer should be very brief. -2.4. What is the difference between the Claims (% of GDP) in Caribbean small states in 2011 and the Claims (% of GDP) in Sierra Leone in 2012?
Make the answer very short. 32.46. What is the difference between the Claims (% of GDP) in Iraq in 2011 and the Claims (% of GDP) in Moldova in 2012?
Your answer should be very brief. -36.23. What is the difference between the Claims (% of GDP) of Iraq in 2011 and the Claims (% of GDP) of Sierra Leone in 2012?
Provide a short and direct response. -1.38. What is the difference between the Claims (% of GDP) in Moldova in 2011 and the Claims (% of GDP) in Sierra Leone in 2012?
Make the answer very short. 29.7. What is the average Claims (% of GDP) in Caribbean small states per year?
Your answer should be compact. 43.4. What is the average Claims (% of GDP) of Iraq per year?
Provide a succinct answer. 4.25. What is the average Claims (% of GDP) in Moldova per year?
Your answer should be compact. 36.55. What is the average Claims (% of GDP) in Sierra Leone per year?
Give a very brief answer. 6.48. In the year 2005, what is the difference between the Claims (% of GDP) of Caribbean small states and Claims (% of GDP) of Iraq?
Your answer should be very brief. 41.7. In the year 2005, what is the difference between the Claims (% of GDP) of Caribbean small states and Claims (% of GDP) of Moldova?
Ensure brevity in your answer.  16.88. In the year 2005, what is the difference between the Claims (% of GDP) of Caribbean small states and Claims (% of GDP) of Sierra Leone?
Give a very brief answer. 40.09. In the year 2005, what is the difference between the Claims (% of GDP) of Iraq and Claims (% of GDP) of Moldova?
Keep it short and to the point. -24.82. In the year 2005, what is the difference between the Claims (% of GDP) in Iraq and Claims (% of GDP) in Sierra Leone?
Your response must be concise. -1.62. In the year 2005, what is the difference between the Claims (% of GDP) of Moldova and Claims (% of GDP) of Sierra Leone?
Your answer should be compact. 23.2. In the year 2006, what is the difference between the Claims (% of GDP) in Caribbean small states and Claims (% of GDP) in Iraq?
Keep it short and to the point. 40.75. In the year 2006, what is the difference between the Claims (% of GDP) of Caribbean small states and Claims (% of GDP) of Moldova?
Offer a terse response. 12.55. In the year 2006, what is the difference between the Claims (% of GDP) in Caribbean small states and Claims (% of GDP) in Sierra Leone?
Keep it short and to the point. 39.91. In the year 2006, what is the difference between the Claims (% of GDP) of Iraq and Claims (% of GDP) of Moldova?
Ensure brevity in your answer.  -28.19. In the year 2006, what is the difference between the Claims (% of GDP) in Iraq and Claims (% of GDP) in Sierra Leone?
Offer a terse response. -0.83. In the year 2006, what is the difference between the Claims (% of GDP) in Moldova and Claims (% of GDP) in Sierra Leone?
Offer a terse response. 27.36. In the year 2007, what is the difference between the Claims (% of GDP) of Caribbean small states and Claims (% of GDP) of Iraq?
Offer a terse response. 42.11. In the year 2007, what is the difference between the Claims (% of GDP) in Caribbean small states and Claims (% of GDP) in Moldova?
Offer a very short reply. 5.42. In the year 2007, what is the difference between the Claims (% of GDP) of Caribbean small states and Claims (% of GDP) of Sierra Leone?
Your response must be concise. 40.03. In the year 2007, what is the difference between the Claims (% of GDP) of Iraq and Claims (% of GDP) of Moldova?
Make the answer very short. -36.69. In the year 2007, what is the difference between the Claims (% of GDP) of Iraq and Claims (% of GDP) of Sierra Leone?
Ensure brevity in your answer.  -2.08. In the year 2007, what is the difference between the Claims (% of GDP) in Moldova and Claims (% of GDP) in Sierra Leone?
Offer a terse response. 34.61. In the year 2008, what is the difference between the Claims (% of GDP) in Caribbean small states and Claims (% of GDP) in Iraq?
Your answer should be very brief. 38.89. In the year 2008, what is the difference between the Claims (% of GDP) of Caribbean small states and Claims (% of GDP) of Moldova?
Offer a very short reply. 1.68. In the year 2008, what is the difference between the Claims (% of GDP) of Caribbean small states and Claims (% of GDP) of Sierra Leone?
Your answer should be very brief. 35.68. In the year 2008, what is the difference between the Claims (% of GDP) of Iraq and Claims (% of GDP) of Moldova?
Ensure brevity in your answer.  -37.21. In the year 2008, what is the difference between the Claims (% of GDP) in Iraq and Claims (% of GDP) in Sierra Leone?
Offer a very short reply. -3.22. In the year 2008, what is the difference between the Claims (% of GDP) of Moldova and Claims (% of GDP) of Sierra Leone?
Provide a succinct answer. 34. In the year 2009, what is the difference between the Claims (% of GDP) in Caribbean small states and Claims (% of GDP) in Iraq?
Give a very brief answer. 46.44. In the year 2009, what is the difference between the Claims (% of GDP) of Caribbean small states and Claims (% of GDP) of Moldova?
Keep it short and to the point. 10.81. In the year 2009, what is the difference between the Claims (% of GDP) in Caribbean small states and Claims (% of GDP) in Sierra Leone?
Provide a succinct answer. 41.39. In the year 2009, what is the difference between the Claims (% of GDP) in Iraq and Claims (% of GDP) in Moldova?
Make the answer very short. -35.64. In the year 2009, what is the difference between the Claims (% of GDP) of Iraq and Claims (% of GDP) of Sierra Leone?
Make the answer very short. -5.05. In the year 2009, what is the difference between the Claims (% of GDP) of Moldova and Claims (% of GDP) of Sierra Leone?
Make the answer very short. 30.59. In the year 2010, what is the difference between the Claims (% of GDP) of Caribbean small states and Claims (% of GDP) of Iraq?
Your response must be concise. 37.17. In the year 2010, what is the difference between the Claims (% of GDP) of Caribbean small states and Claims (% of GDP) of Moldova?
Provide a succinct answer. 6.4. In the year 2010, what is the difference between the Claims (% of GDP) in Caribbean small states and Claims (% of GDP) in Sierra Leone?
Your answer should be compact. 34.04. In the year 2010, what is the difference between the Claims (% of GDP) in Iraq and Claims (% of GDP) in Moldova?
Provide a succinct answer. -30.77. In the year 2010, what is the difference between the Claims (% of GDP) in Iraq and Claims (% of GDP) in Sierra Leone?
Offer a very short reply. -3.13. In the year 2010, what is the difference between the Claims (% of GDP) of Moldova and Claims (% of GDP) of Sierra Leone?
Provide a short and direct response. 27.64. In the year 2011, what is the difference between the Claims (% of GDP) of Caribbean small states and Claims (% of GDP) of Iraq?
Keep it short and to the point. 33.83. In the year 2011, what is the difference between the Claims (% of GDP) in Caribbean small states and Claims (% of GDP) in Moldova?
Offer a terse response. 2.75. In the year 2011, what is the difference between the Claims (% of GDP) of Caribbean small states and Claims (% of GDP) of Sierra Leone?
Offer a very short reply. 31.1. In the year 2011, what is the difference between the Claims (% of GDP) in Iraq and Claims (% of GDP) in Moldova?
Provide a short and direct response. -31.08. In the year 2011, what is the difference between the Claims (% of GDP) in Iraq and Claims (% of GDP) in Sierra Leone?
Offer a terse response. -2.73. In the year 2011, what is the difference between the Claims (% of GDP) in Moldova and Claims (% of GDP) in Sierra Leone?
Provide a short and direct response. 28.35. In the year 2012, what is the difference between the Claims (% of GDP) in Caribbean small states and Claims (% of GDP) in Iraq?
Provide a succinct answer. 32.28. In the year 2012, what is the difference between the Claims (% of GDP) in Caribbean small states and Claims (% of GDP) in Moldova?
Your answer should be compact. -1.74. In the year 2012, what is the difference between the Claims (% of GDP) in Caribbean small states and Claims (% of GDP) in Sierra Leone?
Keep it short and to the point. 33.12. In the year 2012, what is the difference between the Claims (% of GDP) of Iraq and Claims (% of GDP) of Moldova?
Keep it short and to the point. -34.02. In the year 2012, what is the difference between the Claims (% of GDP) in Iraq and Claims (% of GDP) in Sierra Leone?
Your answer should be compact. 0.84. In the year 2012, what is the difference between the Claims (% of GDP) of Moldova and Claims (% of GDP) of Sierra Leone?
Your answer should be compact. 34.86. What is the ratio of the Claims (% of GDP) in Caribbean small states in 2005 to that in 2006?
Provide a short and direct response. 1.01. What is the ratio of the Claims (% of GDP) in Iraq in 2005 to that in 2006?
Keep it short and to the point. 0.78. What is the ratio of the Claims (% of GDP) in Moldova in 2005 to that in 2006?
Your response must be concise. 0.87. What is the ratio of the Claims (% of GDP) in Sierra Leone in 2005 to that in 2006?
Your answer should be very brief. 1.03. What is the ratio of the Claims (% of GDP) of Caribbean small states in 2005 to that in 2007?
Provide a short and direct response. 0.99. What is the ratio of the Claims (% of GDP) of Iraq in 2005 to that in 2007?
Your response must be concise. 0.91. What is the ratio of the Claims (% of GDP) of Moldova in 2005 to that in 2007?
Offer a terse response. 0.69. What is the ratio of the Claims (% of GDP) of Sierra Leone in 2005 to that in 2007?
Your response must be concise. 0.85. What is the ratio of the Claims (% of GDP) of Caribbean small states in 2005 to that in 2008?
Give a very brief answer. 1.06. What is the ratio of the Claims (% of GDP) of Iraq in 2005 to that in 2008?
Offer a terse response. 0.83. What is the ratio of the Claims (% of GDP) of Moldova in 2005 to that in 2008?
Your answer should be compact. 0.68. What is the ratio of the Claims (% of GDP) of Sierra Leone in 2005 to that in 2008?
Your response must be concise. 0.66. What is the ratio of the Claims (% of GDP) of Caribbean small states in 2005 to that in 2009?
Your answer should be compact. 0.87. What is the ratio of the Claims (% of GDP) in Iraq in 2005 to that in 2009?
Offer a very short reply. 0.59. What is the ratio of the Claims (% of GDP) in Moldova in 2005 to that in 2009?
Your answer should be very brief. 0.69. What is the ratio of the Claims (% of GDP) in Sierra Leone in 2005 to that in 2009?
Offer a very short reply. 0.44. What is the ratio of the Claims (% of GDP) of Caribbean small states in 2005 to that in 2010?
Provide a short and direct response. 1.03. What is the ratio of the Claims (% of GDP) of Iraq in 2005 to that in 2010?
Your answer should be very brief. 0.42. What is the ratio of the Claims (% of GDP) of Moldova in 2005 to that in 2010?
Give a very brief answer. 0.75. What is the ratio of the Claims (% of GDP) of Sierra Leone in 2005 to that in 2010?
Keep it short and to the point. 0.46. What is the ratio of the Claims (% of GDP) of Caribbean small states in 2005 to that in 2011?
Give a very brief answer. 1.11. What is the ratio of the Claims (% of GDP) of Iraq in 2005 to that in 2011?
Offer a terse response. 0.4. What is the ratio of the Claims (% of GDP) in Moldova in 2005 to that in 2011?
Your answer should be very brief. 0.74. What is the ratio of the Claims (% of GDP) in Sierra Leone in 2005 to that in 2011?
Offer a terse response. 0.46. What is the ratio of the Claims (% of GDP) in Caribbean small states in 2005 to that in 2012?
Your answer should be very brief. 1.09. What is the ratio of the Claims (% of GDP) of Iraq in 2005 to that in 2012?
Keep it short and to the point. 0.29. What is the ratio of the Claims (% of GDP) in Moldova in 2005 to that in 2012?
Offer a very short reply. 0.65. What is the ratio of the Claims (% of GDP) in Sierra Leone in 2005 to that in 2012?
Offer a terse response. 0.55. What is the ratio of the Claims (% of GDP) of Caribbean small states in 2006 to that in 2007?
Your response must be concise. 0.98. What is the ratio of the Claims (% of GDP) of Iraq in 2006 to that in 2007?
Offer a terse response. 1.17. What is the ratio of the Claims (% of GDP) of Moldova in 2006 to that in 2007?
Offer a terse response. 0.79. What is the ratio of the Claims (% of GDP) in Sierra Leone in 2006 to that in 2007?
Keep it short and to the point. 0.82. What is the ratio of the Claims (% of GDP) of Caribbean small states in 2006 to that in 2008?
Provide a succinct answer. 1.05. What is the ratio of the Claims (% of GDP) in Iraq in 2006 to that in 2008?
Ensure brevity in your answer.  1.07. What is the ratio of the Claims (% of GDP) in Moldova in 2006 to that in 2008?
Your response must be concise. 0.78. What is the ratio of the Claims (% of GDP) of Sierra Leone in 2006 to that in 2008?
Give a very brief answer. 0.63. What is the ratio of the Claims (% of GDP) of Caribbean small states in 2006 to that in 2009?
Give a very brief answer. 0.87. What is the ratio of the Claims (% of GDP) in Iraq in 2006 to that in 2009?
Your answer should be very brief. 0.76. What is the ratio of the Claims (% of GDP) in Moldova in 2006 to that in 2009?
Make the answer very short. 0.79. What is the ratio of the Claims (% of GDP) of Sierra Leone in 2006 to that in 2009?
Ensure brevity in your answer.  0.43. What is the ratio of the Claims (% of GDP) in Caribbean small states in 2006 to that in 2010?
Your answer should be very brief. 1.02. What is the ratio of the Claims (% of GDP) in Iraq in 2006 to that in 2010?
Offer a terse response. 0.54. What is the ratio of the Claims (% of GDP) in Moldova in 2006 to that in 2010?
Provide a short and direct response. 0.86. What is the ratio of the Claims (% of GDP) of Sierra Leone in 2006 to that in 2010?
Offer a very short reply. 0.44. What is the ratio of the Claims (% of GDP) in Caribbean small states in 2006 to that in 2011?
Offer a very short reply. 1.1. What is the ratio of the Claims (% of GDP) of Iraq in 2006 to that in 2011?
Offer a very short reply. 0.51. What is the ratio of the Claims (% of GDP) of Moldova in 2006 to that in 2011?
Offer a very short reply. 0.84. What is the ratio of the Claims (% of GDP) in Sierra Leone in 2006 to that in 2011?
Make the answer very short. 0.45. What is the ratio of the Claims (% of GDP) in Caribbean small states in 2006 to that in 2012?
Offer a terse response. 1.08. What is the ratio of the Claims (% of GDP) in Iraq in 2006 to that in 2012?
Provide a succinct answer. 0.37. What is the ratio of the Claims (% of GDP) of Moldova in 2006 to that in 2012?
Offer a very short reply. 0.74. What is the ratio of the Claims (% of GDP) in Sierra Leone in 2006 to that in 2012?
Your response must be concise. 0.53. What is the ratio of the Claims (% of GDP) of Caribbean small states in 2007 to that in 2008?
Provide a short and direct response. 1.07. What is the ratio of the Claims (% of GDP) in Iraq in 2007 to that in 2008?
Your answer should be very brief. 0.91. What is the ratio of the Claims (% of GDP) of Moldova in 2007 to that in 2008?
Ensure brevity in your answer.  0.98. What is the ratio of the Claims (% of GDP) of Sierra Leone in 2007 to that in 2008?
Offer a very short reply. 0.77. What is the ratio of the Claims (% of GDP) in Caribbean small states in 2007 to that in 2009?
Provide a succinct answer. 0.89. What is the ratio of the Claims (% of GDP) of Iraq in 2007 to that in 2009?
Your response must be concise. 0.65. What is the ratio of the Claims (% of GDP) in Moldova in 2007 to that in 2009?
Give a very brief answer. 0.99. What is the ratio of the Claims (% of GDP) of Sierra Leone in 2007 to that in 2009?
Offer a very short reply. 0.52. What is the ratio of the Claims (% of GDP) in Caribbean small states in 2007 to that in 2010?
Provide a succinct answer. 1.05. What is the ratio of the Claims (% of GDP) in Iraq in 2007 to that in 2010?
Provide a short and direct response. 0.46. What is the ratio of the Claims (% of GDP) of Moldova in 2007 to that in 2010?
Keep it short and to the point. 1.08. What is the ratio of the Claims (% of GDP) in Sierra Leone in 2007 to that in 2010?
Your answer should be compact. 0.54. What is the ratio of the Claims (% of GDP) in Caribbean small states in 2007 to that in 2011?
Your answer should be compact. 1.13. What is the ratio of the Claims (% of GDP) in Iraq in 2007 to that in 2011?
Offer a very short reply. 0.44. What is the ratio of the Claims (% of GDP) in Moldova in 2007 to that in 2011?
Ensure brevity in your answer.  1.06. What is the ratio of the Claims (% of GDP) of Sierra Leone in 2007 to that in 2011?
Offer a very short reply. 0.54. What is the ratio of the Claims (% of GDP) of Caribbean small states in 2007 to that in 2012?
Keep it short and to the point. 1.11. What is the ratio of the Claims (% of GDP) of Iraq in 2007 to that in 2012?
Provide a short and direct response. 0.32. What is the ratio of the Claims (% of GDP) in Moldova in 2007 to that in 2012?
Your answer should be compact. 0.93. What is the ratio of the Claims (% of GDP) in Sierra Leone in 2007 to that in 2012?
Make the answer very short. 0.64. What is the ratio of the Claims (% of GDP) of Caribbean small states in 2008 to that in 2009?
Give a very brief answer. 0.83. What is the ratio of the Claims (% of GDP) of Iraq in 2008 to that in 2009?
Ensure brevity in your answer.  0.71. What is the ratio of the Claims (% of GDP) of Moldova in 2008 to that in 2009?
Your response must be concise. 1.01. What is the ratio of the Claims (% of GDP) of Sierra Leone in 2008 to that in 2009?
Your answer should be compact. 0.67. What is the ratio of the Claims (% of GDP) of Caribbean small states in 2008 to that in 2010?
Make the answer very short. 0.98. What is the ratio of the Claims (% of GDP) in Iraq in 2008 to that in 2010?
Your response must be concise. 0.51. What is the ratio of the Claims (% of GDP) in Moldova in 2008 to that in 2010?
Give a very brief answer. 1.1. What is the ratio of the Claims (% of GDP) of Sierra Leone in 2008 to that in 2010?
Give a very brief answer. 0.7. What is the ratio of the Claims (% of GDP) of Caribbean small states in 2008 to that in 2011?
Your response must be concise. 1.05. What is the ratio of the Claims (% of GDP) in Iraq in 2008 to that in 2011?
Keep it short and to the point. 0.48. What is the ratio of the Claims (% of GDP) of Moldova in 2008 to that in 2011?
Keep it short and to the point. 1.08. What is the ratio of the Claims (% of GDP) in Sierra Leone in 2008 to that in 2011?
Offer a very short reply. 0.7. What is the ratio of the Claims (% of GDP) of Caribbean small states in 2008 to that in 2012?
Your answer should be compact. 1.03. What is the ratio of the Claims (% of GDP) of Iraq in 2008 to that in 2012?
Provide a short and direct response. 0.35. What is the ratio of the Claims (% of GDP) in Moldova in 2008 to that in 2012?
Make the answer very short. 0.95. What is the ratio of the Claims (% of GDP) in Sierra Leone in 2008 to that in 2012?
Your answer should be compact. 0.84. What is the ratio of the Claims (% of GDP) in Caribbean small states in 2009 to that in 2010?
Your response must be concise. 1.18. What is the ratio of the Claims (% of GDP) in Iraq in 2009 to that in 2010?
Your response must be concise. 0.71. What is the ratio of the Claims (% of GDP) of Moldova in 2009 to that in 2010?
Offer a terse response. 1.09. What is the ratio of the Claims (% of GDP) of Sierra Leone in 2009 to that in 2010?
Give a very brief answer. 1.04. What is the ratio of the Claims (% of GDP) of Caribbean small states in 2009 to that in 2011?
Your answer should be very brief. 1.27. What is the ratio of the Claims (% of GDP) in Iraq in 2009 to that in 2011?
Offer a very short reply. 0.67. What is the ratio of the Claims (% of GDP) in Moldova in 2009 to that in 2011?
Offer a terse response. 1.07. What is the ratio of the Claims (% of GDP) in Sierra Leone in 2009 to that in 2011?
Ensure brevity in your answer.  1.05. What is the ratio of the Claims (% of GDP) in Caribbean small states in 2009 to that in 2012?
Your response must be concise. 1.25. What is the ratio of the Claims (% of GDP) in Iraq in 2009 to that in 2012?
Your answer should be compact. 0.49. What is the ratio of the Claims (% of GDP) in Moldova in 2009 to that in 2012?
Your answer should be very brief. 0.94. What is the ratio of the Claims (% of GDP) of Sierra Leone in 2009 to that in 2012?
Offer a terse response. 1.25. What is the ratio of the Claims (% of GDP) of Caribbean small states in 2010 to that in 2011?
Your response must be concise. 1.08. What is the ratio of the Claims (% of GDP) in Iraq in 2010 to that in 2011?
Offer a very short reply. 0.95. What is the ratio of the Claims (% of GDP) in Moldova in 2010 to that in 2011?
Provide a succinct answer. 0.98. What is the ratio of the Claims (% of GDP) of Sierra Leone in 2010 to that in 2011?
Give a very brief answer. 1.01. What is the ratio of the Claims (% of GDP) of Caribbean small states in 2010 to that in 2012?
Offer a terse response. 1.06. What is the ratio of the Claims (% of GDP) of Iraq in 2010 to that in 2012?
Offer a terse response. 0.69. What is the ratio of the Claims (% of GDP) of Moldova in 2010 to that in 2012?
Your response must be concise. 0.86. What is the ratio of the Claims (% of GDP) of Sierra Leone in 2010 to that in 2012?
Offer a very short reply. 1.2. What is the ratio of the Claims (% of GDP) in Caribbean small states in 2011 to that in 2012?
Ensure brevity in your answer.  0.98. What is the ratio of the Claims (% of GDP) of Iraq in 2011 to that in 2012?
Offer a terse response. 0.72. What is the ratio of the Claims (% of GDP) of Moldova in 2011 to that in 2012?
Your answer should be very brief. 0.88. What is the ratio of the Claims (% of GDP) in Sierra Leone in 2011 to that in 2012?
Offer a very short reply. 1.19. What is the difference between the highest and the second highest Claims (% of GDP) in Caribbean small states?
Offer a very short reply. 5.71. What is the difference between the highest and the second highest Claims (% of GDP) in Iraq?
Offer a very short reply. 2.22. What is the difference between the highest and the second highest Claims (% of GDP) in Moldova?
Offer a very short reply. 2.05. What is the difference between the highest and the second highest Claims (% of GDP) in Sierra Leone?
Offer a very short reply. 0.34. What is the difference between the highest and the lowest Claims (% of GDP) in Caribbean small states?
Provide a short and direct response. 10.71. What is the difference between the highest and the lowest Claims (% of GDP) in Iraq?
Offer a very short reply. 5.72. What is the difference between the highest and the lowest Claims (% of GDP) of Moldova?
Your response must be concise. 14.91. What is the difference between the highest and the lowest Claims (% of GDP) of Sierra Leone?
Your answer should be very brief. 5.16. 